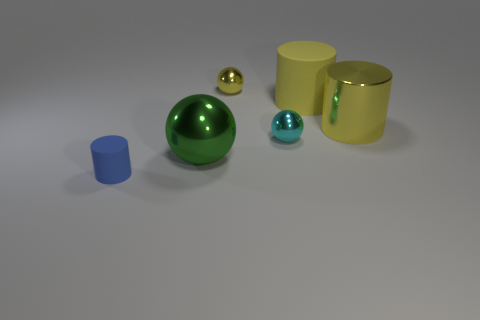Subtract all brown cylinders. Subtract all yellow balls. How many cylinders are left? 3 Add 2 small blue cylinders. How many objects exist? 8 Subtract 1 green balls. How many objects are left? 5 Subtract all brown metal objects. Subtract all blue matte things. How many objects are left? 5 Add 1 yellow things. How many yellow things are left? 4 Add 6 yellow cylinders. How many yellow cylinders exist? 8 